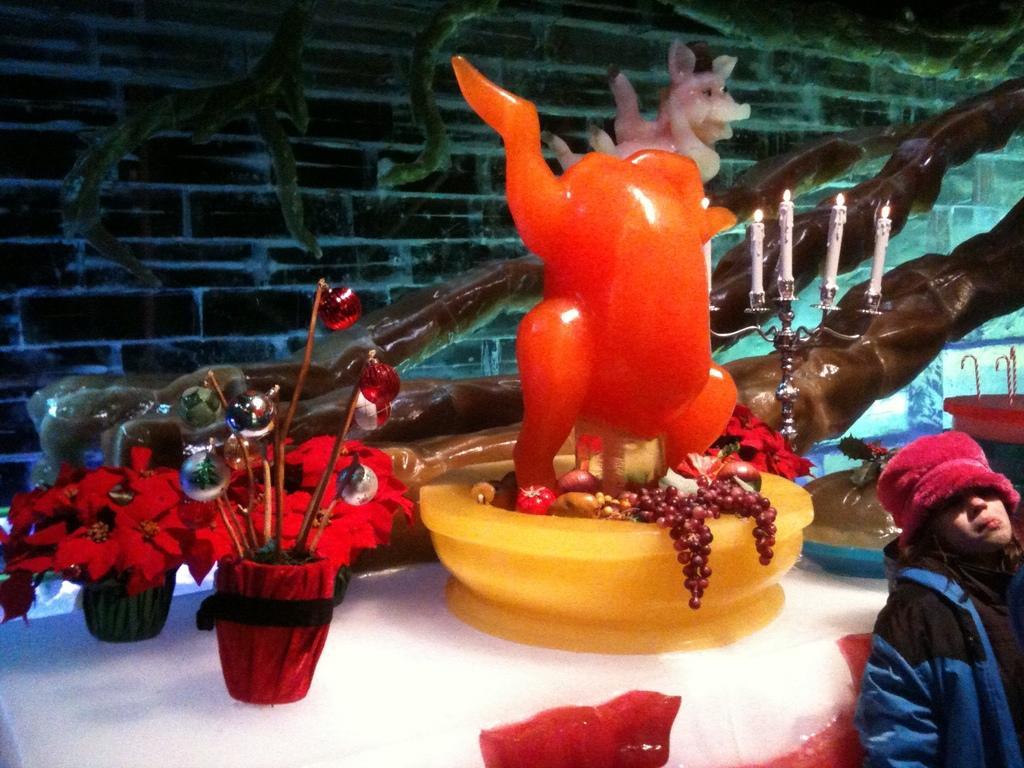How would you summarize this image in a sentence or two? In this image we can see there are few flower pots and some toys on the table. On the bottom right side there is a girl. 